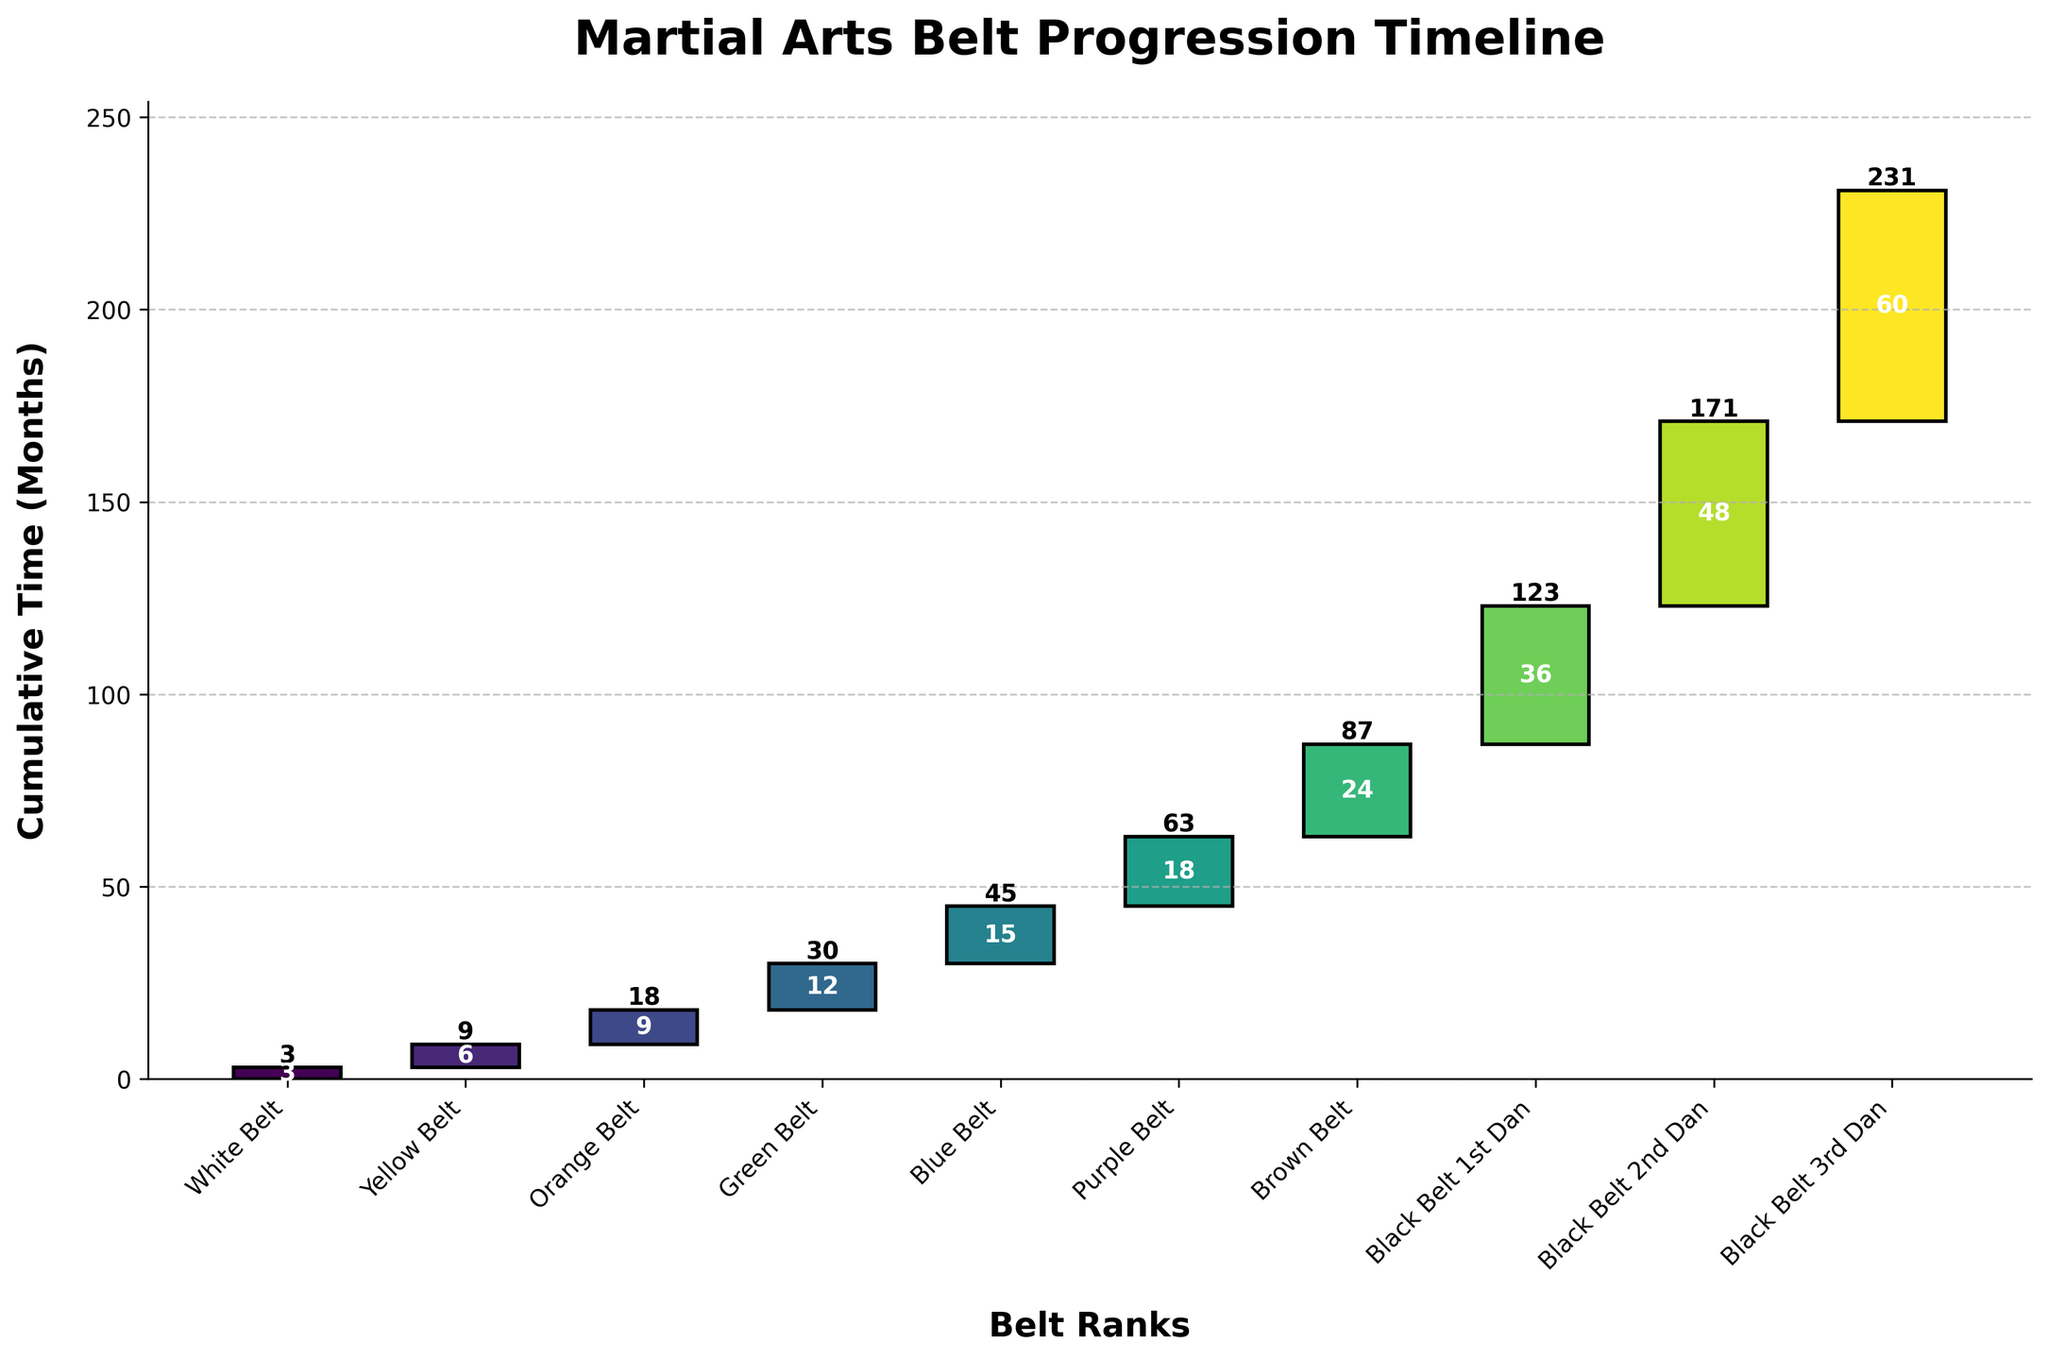How many months does it take to achieve a Black Belt 1st Dan? The figure shows the cumulative time for each belt rank. For Black Belt 1st Dan, the cumulative time is listed as 36 months.
Answer: 36 months Which belt rank requires the most time to progress to the next level? By looking at the time duration spent on each belt, Brown Belt requires 24 months, which is the highest among all the belts.
Answer: Brown Belt What is the total time spent progressing from White Belt to Blue Belt? Add the months spent at each belt from White Belt to Blue Belt: 3 (White) + 6 (Yellow) + 9 (Orange) + 12 (Green) + 15 (Blue) = 45 months.
Answer: 45 months How much more time is required to reach Black Belt 2nd Dan compared to Black Belt 1st Dan? The cumulative time for Black Belt 1st Dan is 36 months, and for Black Belt 2nd Dan is 48 months. The difference is 48 - 36 = 12 months.
Answer: 12 months What is the cumulative time taken to achieve Purple Belt? The cumulative time for Purple Belt is listed as 18 months on the figure.
Answer: 18 months Which ranks cumulatively sum up to less than the time needed to achieve Black Belt 3rd Dan? Black Belt 3rd Dan takes 60 months. Summing up cumulative times of ranks up to Purple Belt: 3 (White) + 6 (Yellow) + 9 (Orange) + 12 (Green) + 15 (Blue) + 18 (Purple) = 63 months, which is more than 60. So, consider lower ranks. Up to Purple Belt is: 18 months + 24 (Brown) = 42 months, less than 60.
Answer: Ranks up to Brown Belt What is the difference in time spent between the first three belts (White, Yellow, Orange) and the next three belts (Green, Blue, Purple)? Sum of first three belts: 3 (White) + 6 (Yellow) + 9 (Orange) = 18 months. Sum of the next three belts: 12 (Green) + 15 (Blue) + 18 (Purple) = 45 months. Difference is 45 - 18 = 27 months.
Answer: 27 months Which belt rank requires exactly three times as much time as the White Belt to achieve? White Belt takes 3 months. 3 times this is 3 * 3 = 9 months, which matches the time required for Orange Belt.
Answer: Orange Belt 